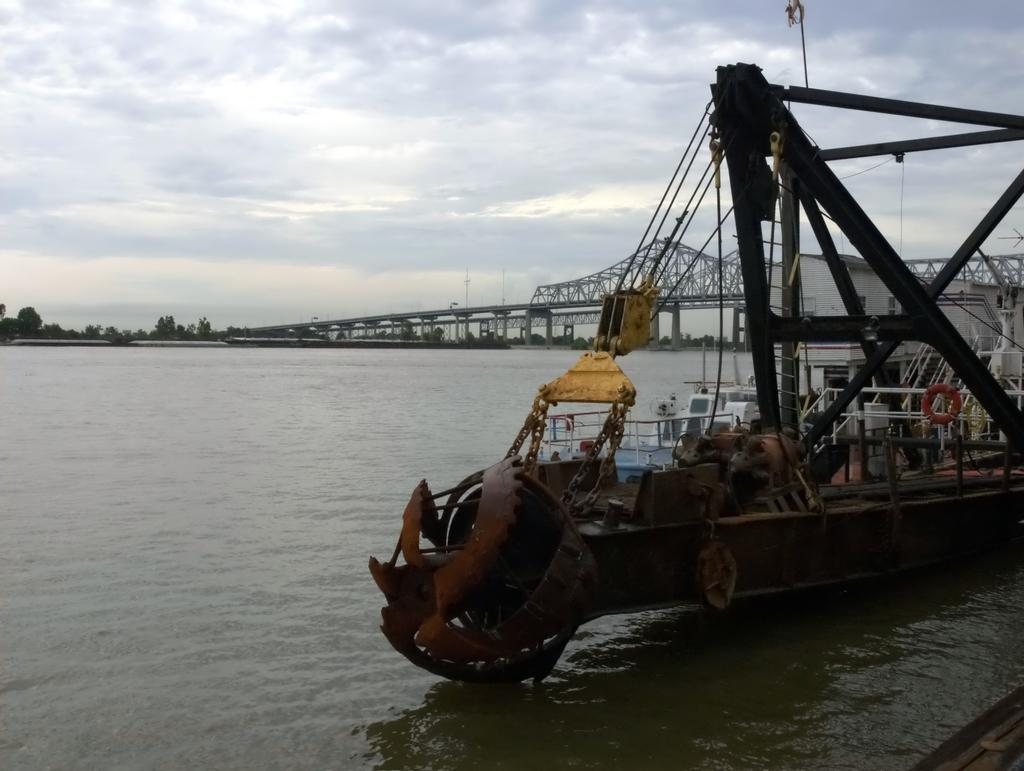What is the main subject of the image? The main subject of the image is a ship. Where is the ship located? The ship is on a river. What other structures can be seen in the image? There is a bridge in the image. What can be seen in the background of the image? There are trees and the sky visible in the background of the image. What reason does the ship have for being on fire in the image? There is no indication in the image that the ship is on fire, so it cannot be determined from the picture. 